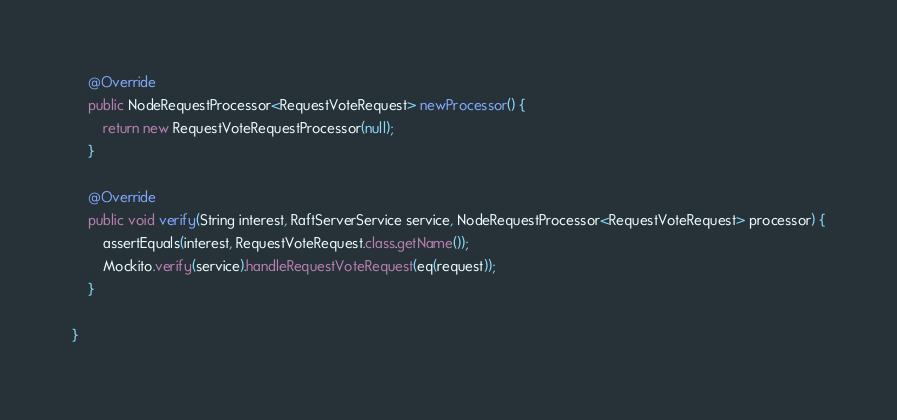Convert code to text. <code><loc_0><loc_0><loc_500><loc_500><_Java_>    @Override
    public NodeRequestProcessor<RequestVoteRequest> newProcessor() {
        return new RequestVoteRequestProcessor(null);
    }

    @Override
    public void verify(String interest, RaftServerService service, NodeRequestProcessor<RequestVoteRequest> processor) {
        assertEquals(interest, RequestVoteRequest.class.getName());
        Mockito.verify(service).handleRequestVoteRequest(eq(request));
    }

}
</code> 